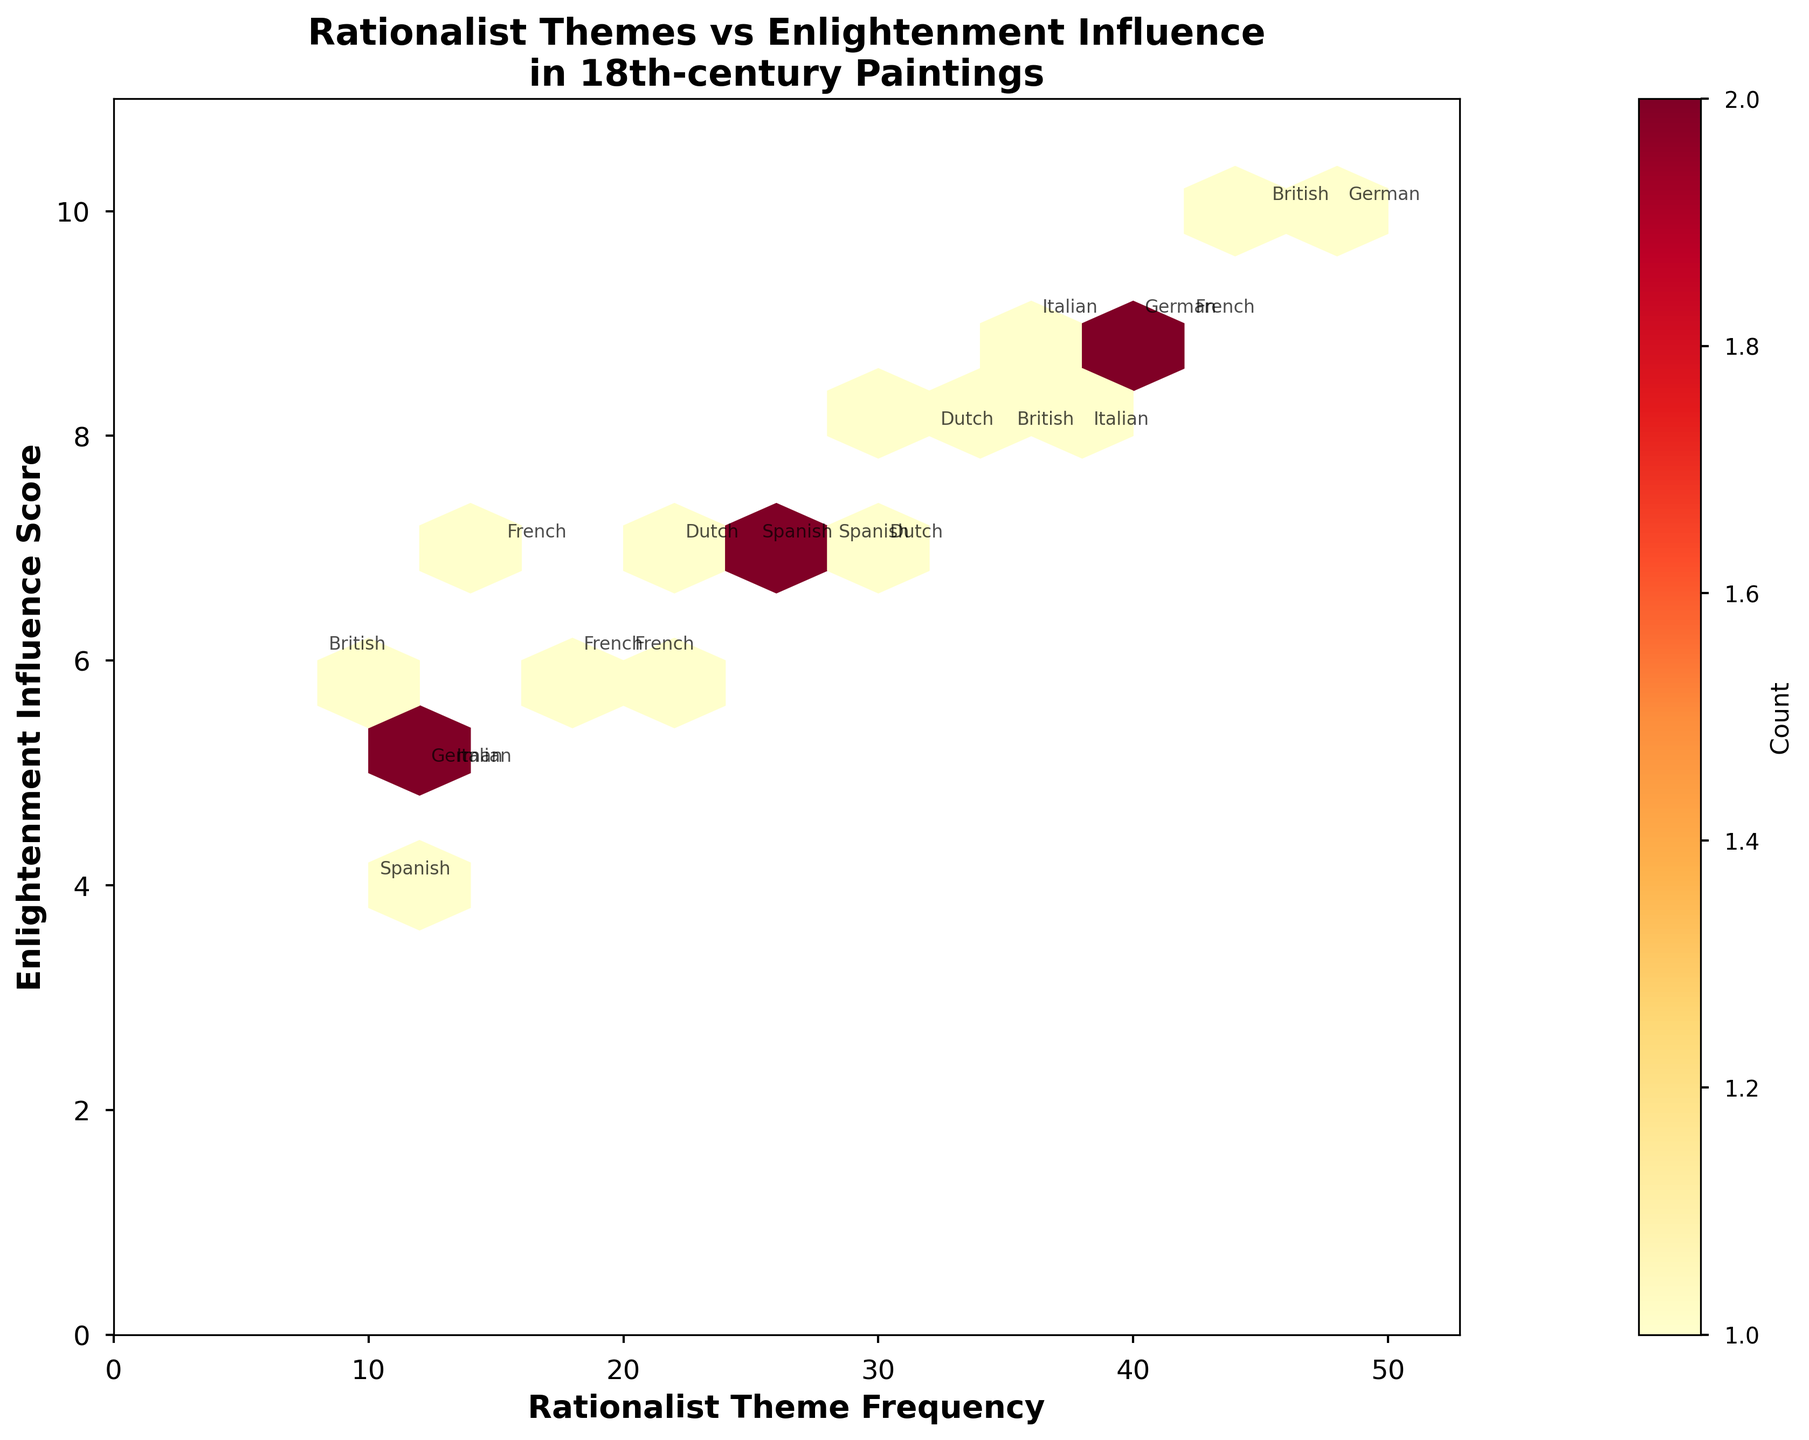What are the axes titles in the plot? The axes titles can be found by looking at the labels on the x-axis and y-axis of the plot. The x-axis is labeled 'Rationalist Theme Frequency' and the y-axis is labeled 'Enlightenment Influence Score'.
Answer: 'Rationalist Theme Frequency' and 'Enlightenment Influence Score' What is the color of the hexagons with the highest density? The color of the hexagons varies based on density. The hexagons with the highest density are colored towards the 'red' end of the 'YlOrRd' colormap.
Answer: Red Which nationality appears most frequently in the data points within the plot? By looking at the annotations for artist nationality across the data points, the 'French' nationality appears most frequently as it is present in Rococo, Neoclassicism, Baroque, and Romanticism movements.
Answer: French What's the Enlightenment Influence Score range depicted on the y-axis? The y-axis shows values ranging from 0 to slightly above 10, determined by the ylim settings, which extend to about 11 to provide adequate space around the data points.
Answer: 0 to around 11 What is the Rationalist Theme Frequency for the data point with the highest Enlightenment Influence Score? By finding the data point with the highest y-axis value, which is 48 (Enlightenment Influence Score), we can see the Rationalist Theme Frequency corresponding to it, which is 48.
Answer: 48 How many hexagons are colored in shades of yellow? The colorbar helps determine the count per hexagon, and visually, we observe the hexagons colored in shades of yellow representing lower densities. In total, there are 3 hexagons in shades of yellow.
Answer: 3 Which Artistic Movement has the highest Rationalist Theme Frequency value? Reviewing the hexagons and annotations, the maximum x-axis value marked for a data point is 48 under 'Enlightenment Era' for the 'British' nationality.
Answer: Enlightenment Era How does the Rationalist Theme Frequency of British Enlightenment Era paintings compare to those of German Neoclassicism paintings? British Enlightenment Era paintings show a Rationalist Theme Frequency of 45, while German Neoclassicism paintings show 40, making British higher.
Answer: British Enlightenment Era is higher What is the count of hexagons with overlapping Artist Nationality annotations? Hexagons with more than one annotation indicate overlap. Specifically, there are 2 such hexagons: French with Rococo and Baroque, and another for French and German Neoclassicism.
Answer: 2 